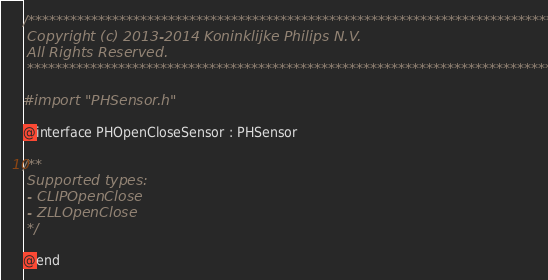<code> <loc_0><loc_0><loc_500><loc_500><_C_>/*******************************************************************************
 Copyright (c) 2013-2014 Koninklijke Philips N.V.
 All Rights Reserved.
 ********************************************************************************/

#import "PHSensor.h"

@interface PHOpenCloseSensor : PHSensor

/**
 Supported types:
 - CLIPOpenClose
 - ZLLOpenClose
 */

@end
</code> 